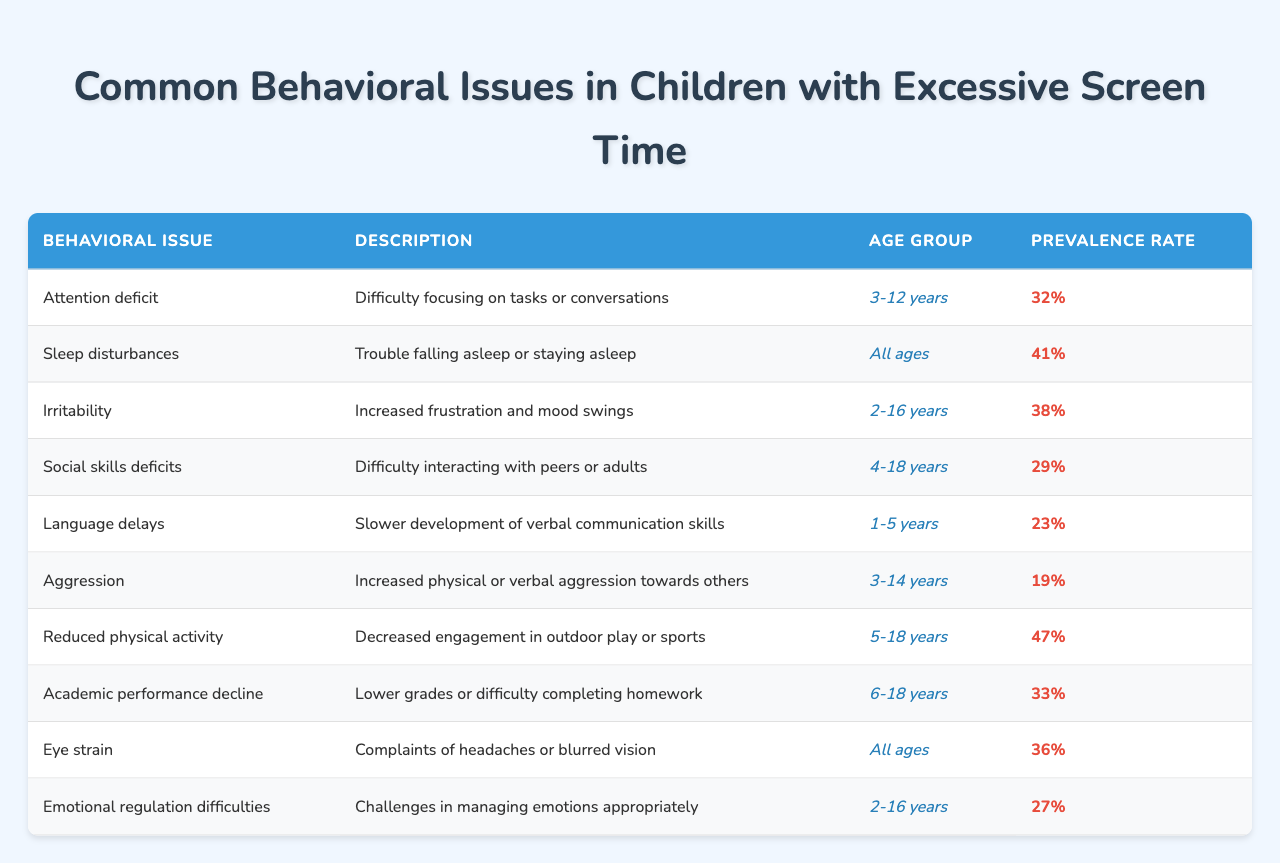What is the prevalence rate of attention deficit in children? The table indicates that the prevalence rate of attention deficit is stated as 32%.
Answer: 32% How many behavioral issues listed apply to the age group of 2-16 years? The table lists three issues for the age group of 2-16 years: irritability, emotional regulation difficulties, and sleep disturbances.
Answer: 3 What is the prevalence rate for language delays? According to the table, the prevalence rate for language delays is 23%.
Answer: 23% Is the prevalence rate of reduced physical activity higher than that of aggression? The prevalence rate for reduced physical activity is 47%, while aggression has a prevalence rate of 19%. Since 47% is greater than 19%, the statement is true.
Answer: Yes Which behavioral issue has the highest prevalence rate? By comparing the prevalence rates in the table, reduced physical activity at 47% is the highest among the listed issues.
Answer: Reduced physical activity What is the average prevalence rate of the listed behavioral issues? To find the average, we add the prevalence rates: (32 + 41 + 38 + 29 + 23 + 19 + 47 + 33 + 36 + 27) =  392. Since there are 10 issues, the average is 392/10 = 39.2%.
Answer: 39.2% Are sleep disturbances and eye strain applicable to all age groups? The table specifies that both sleep disturbances and eye strain are listed for all ages, indicating they do apply to all age groups.
Answer: Yes What age group is most affected by social skills deficits? The table identifies the age group affected by social skills deficits as 4-18 years.
Answer: 4-18 years If a parent is concerned about academic performance decline, what is the prevalence rate? Referring to the table, the prevalence rate for academic performance decline is 33%.
Answer: 33% How many issues have a prevalence rate greater than 36%? The issues with prevalence rates greater than 36% are sleep disturbances (41%), reduced physical activity (47%), and eye strain (36%), totaling 3 issues.
Answer: 3 